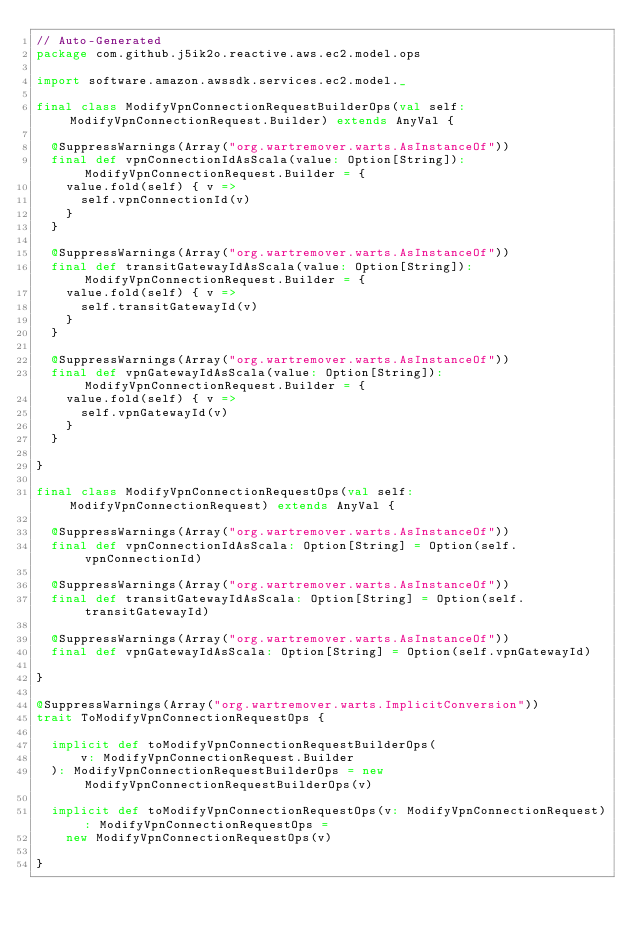Convert code to text. <code><loc_0><loc_0><loc_500><loc_500><_Scala_>// Auto-Generated
package com.github.j5ik2o.reactive.aws.ec2.model.ops

import software.amazon.awssdk.services.ec2.model._

final class ModifyVpnConnectionRequestBuilderOps(val self: ModifyVpnConnectionRequest.Builder) extends AnyVal {

  @SuppressWarnings(Array("org.wartremover.warts.AsInstanceOf"))
  final def vpnConnectionIdAsScala(value: Option[String]): ModifyVpnConnectionRequest.Builder = {
    value.fold(self) { v =>
      self.vpnConnectionId(v)
    }
  }

  @SuppressWarnings(Array("org.wartremover.warts.AsInstanceOf"))
  final def transitGatewayIdAsScala(value: Option[String]): ModifyVpnConnectionRequest.Builder = {
    value.fold(self) { v =>
      self.transitGatewayId(v)
    }
  }

  @SuppressWarnings(Array("org.wartremover.warts.AsInstanceOf"))
  final def vpnGatewayIdAsScala(value: Option[String]): ModifyVpnConnectionRequest.Builder = {
    value.fold(self) { v =>
      self.vpnGatewayId(v)
    }
  }

}

final class ModifyVpnConnectionRequestOps(val self: ModifyVpnConnectionRequest) extends AnyVal {

  @SuppressWarnings(Array("org.wartremover.warts.AsInstanceOf"))
  final def vpnConnectionIdAsScala: Option[String] = Option(self.vpnConnectionId)

  @SuppressWarnings(Array("org.wartremover.warts.AsInstanceOf"))
  final def transitGatewayIdAsScala: Option[String] = Option(self.transitGatewayId)

  @SuppressWarnings(Array("org.wartremover.warts.AsInstanceOf"))
  final def vpnGatewayIdAsScala: Option[String] = Option(self.vpnGatewayId)

}

@SuppressWarnings(Array("org.wartremover.warts.ImplicitConversion"))
trait ToModifyVpnConnectionRequestOps {

  implicit def toModifyVpnConnectionRequestBuilderOps(
      v: ModifyVpnConnectionRequest.Builder
  ): ModifyVpnConnectionRequestBuilderOps = new ModifyVpnConnectionRequestBuilderOps(v)

  implicit def toModifyVpnConnectionRequestOps(v: ModifyVpnConnectionRequest): ModifyVpnConnectionRequestOps =
    new ModifyVpnConnectionRequestOps(v)

}
</code> 